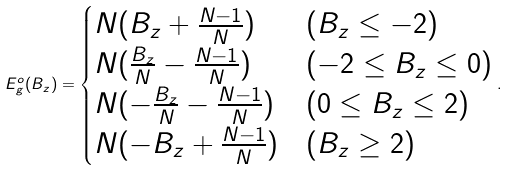<formula> <loc_0><loc_0><loc_500><loc_500>E _ { g } ^ { o } ( B _ { z } ) = \begin{cases} N ( B _ { z } + \frac { N - 1 } { N } ) & ( B _ { z } \leq - 2 ) \\ N ( \frac { B _ { z } } { N } - \frac { N - 1 } { N } ) & ( - 2 \leq B _ { z } \leq 0 ) \\ N ( - \frac { B _ { z } } { N } - \frac { N - 1 } { N } ) & ( 0 \leq B _ { z } \leq 2 ) \\ N ( - B _ { z } + \frac { N - 1 } { N } ) & ( B _ { z } \geq 2 ) \end{cases} .</formula> 